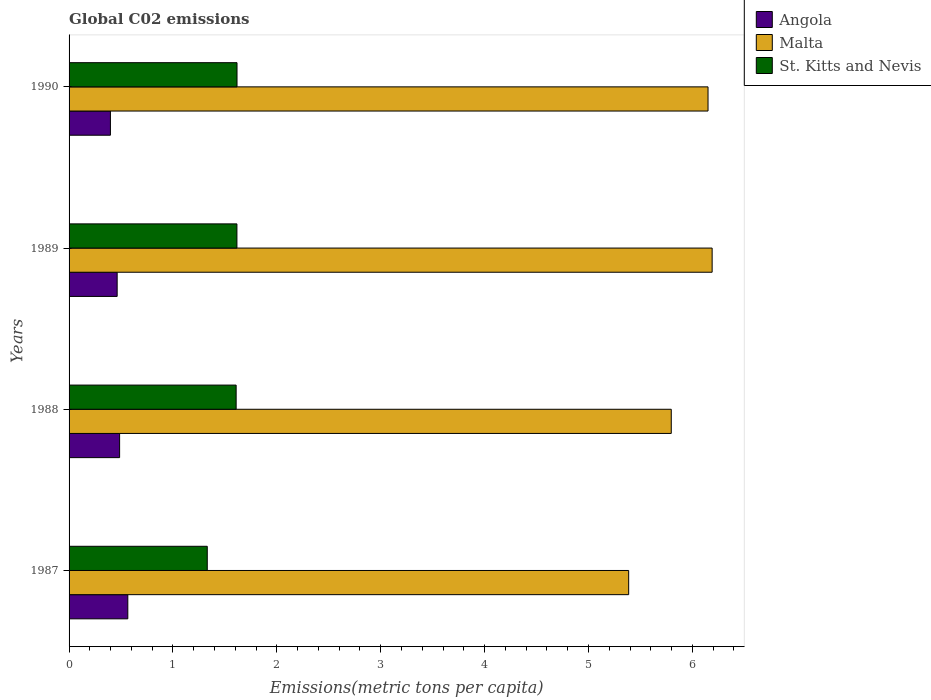How many groups of bars are there?
Provide a succinct answer. 4. Are the number of bars per tick equal to the number of legend labels?
Provide a succinct answer. Yes. Are the number of bars on each tick of the Y-axis equal?
Your answer should be compact. Yes. How many bars are there on the 2nd tick from the top?
Ensure brevity in your answer.  3. What is the label of the 4th group of bars from the top?
Your answer should be compact. 1987. What is the amount of CO2 emitted in in Angola in 1988?
Give a very brief answer. 0.49. Across all years, what is the maximum amount of CO2 emitted in in St. Kitts and Nevis?
Offer a terse response. 1.62. Across all years, what is the minimum amount of CO2 emitted in in Angola?
Ensure brevity in your answer.  0.4. In which year was the amount of CO2 emitted in in Malta maximum?
Give a very brief answer. 1989. In which year was the amount of CO2 emitted in in St. Kitts and Nevis minimum?
Your answer should be compact. 1987. What is the total amount of CO2 emitted in in St. Kitts and Nevis in the graph?
Your answer should be very brief. 6.17. What is the difference between the amount of CO2 emitted in in Angola in 1987 and that in 1990?
Your answer should be very brief. 0.17. What is the difference between the amount of CO2 emitted in in Angola in 1987 and the amount of CO2 emitted in in St. Kitts and Nevis in 1989?
Your answer should be very brief. -1.05. What is the average amount of CO2 emitted in in St. Kitts and Nevis per year?
Keep it short and to the point. 1.54. In the year 1987, what is the difference between the amount of CO2 emitted in in Angola and amount of CO2 emitted in in St. Kitts and Nevis?
Give a very brief answer. -0.76. In how many years, is the amount of CO2 emitted in in St. Kitts and Nevis greater than 2 metric tons per capita?
Make the answer very short. 0. What is the ratio of the amount of CO2 emitted in in St. Kitts and Nevis in 1987 to that in 1988?
Make the answer very short. 0.83. Is the amount of CO2 emitted in in St. Kitts and Nevis in 1989 less than that in 1990?
Your response must be concise. Yes. What is the difference between the highest and the second highest amount of CO2 emitted in in Angola?
Offer a very short reply. 0.08. What is the difference between the highest and the lowest amount of CO2 emitted in in Malta?
Offer a very short reply. 0.8. In how many years, is the amount of CO2 emitted in in St. Kitts and Nevis greater than the average amount of CO2 emitted in in St. Kitts and Nevis taken over all years?
Ensure brevity in your answer.  3. What does the 3rd bar from the top in 1988 represents?
Your response must be concise. Angola. What does the 2nd bar from the bottom in 1990 represents?
Give a very brief answer. Malta. How many years are there in the graph?
Keep it short and to the point. 4. What is the difference between two consecutive major ticks on the X-axis?
Give a very brief answer. 1. How are the legend labels stacked?
Your answer should be very brief. Vertical. What is the title of the graph?
Your answer should be compact. Global C02 emissions. Does "Eritrea" appear as one of the legend labels in the graph?
Offer a terse response. No. What is the label or title of the X-axis?
Ensure brevity in your answer.  Emissions(metric tons per capita). What is the label or title of the Y-axis?
Your answer should be very brief. Years. What is the Emissions(metric tons per capita) of Angola in 1987?
Provide a succinct answer. 0.57. What is the Emissions(metric tons per capita) of Malta in 1987?
Provide a succinct answer. 5.39. What is the Emissions(metric tons per capita) in St. Kitts and Nevis in 1987?
Keep it short and to the point. 1.33. What is the Emissions(metric tons per capita) of Angola in 1988?
Ensure brevity in your answer.  0.49. What is the Emissions(metric tons per capita) of Malta in 1988?
Provide a succinct answer. 5.8. What is the Emissions(metric tons per capita) of St. Kitts and Nevis in 1988?
Your response must be concise. 1.61. What is the Emissions(metric tons per capita) in Angola in 1989?
Your answer should be very brief. 0.46. What is the Emissions(metric tons per capita) in Malta in 1989?
Your response must be concise. 6.19. What is the Emissions(metric tons per capita) of St. Kitts and Nevis in 1989?
Provide a succinct answer. 1.62. What is the Emissions(metric tons per capita) of Angola in 1990?
Offer a terse response. 0.4. What is the Emissions(metric tons per capita) of Malta in 1990?
Your response must be concise. 6.15. What is the Emissions(metric tons per capita) in St. Kitts and Nevis in 1990?
Offer a terse response. 1.62. Across all years, what is the maximum Emissions(metric tons per capita) in Angola?
Provide a succinct answer. 0.57. Across all years, what is the maximum Emissions(metric tons per capita) of Malta?
Offer a terse response. 6.19. Across all years, what is the maximum Emissions(metric tons per capita) in St. Kitts and Nevis?
Provide a succinct answer. 1.62. Across all years, what is the minimum Emissions(metric tons per capita) in Angola?
Provide a short and direct response. 0.4. Across all years, what is the minimum Emissions(metric tons per capita) in Malta?
Your answer should be very brief. 5.39. Across all years, what is the minimum Emissions(metric tons per capita) of St. Kitts and Nevis?
Offer a very short reply. 1.33. What is the total Emissions(metric tons per capita) in Angola in the graph?
Your answer should be compact. 1.91. What is the total Emissions(metric tons per capita) of Malta in the graph?
Offer a very short reply. 23.52. What is the total Emissions(metric tons per capita) in St. Kitts and Nevis in the graph?
Give a very brief answer. 6.17. What is the difference between the Emissions(metric tons per capita) in Angola in 1987 and that in 1988?
Make the answer very short. 0.08. What is the difference between the Emissions(metric tons per capita) in Malta in 1987 and that in 1988?
Your response must be concise. -0.41. What is the difference between the Emissions(metric tons per capita) in St. Kitts and Nevis in 1987 and that in 1988?
Offer a very short reply. -0.28. What is the difference between the Emissions(metric tons per capita) of Angola in 1987 and that in 1989?
Ensure brevity in your answer.  0.1. What is the difference between the Emissions(metric tons per capita) in Malta in 1987 and that in 1989?
Your answer should be compact. -0.8. What is the difference between the Emissions(metric tons per capita) of St. Kitts and Nevis in 1987 and that in 1989?
Provide a short and direct response. -0.29. What is the difference between the Emissions(metric tons per capita) in Angola in 1987 and that in 1990?
Offer a terse response. 0.17. What is the difference between the Emissions(metric tons per capita) in Malta in 1987 and that in 1990?
Provide a succinct answer. -0.76. What is the difference between the Emissions(metric tons per capita) in St. Kitts and Nevis in 1987 and that in 1990?
Make the answer very short. -0.29. What is the difference between the Emissions(metric tons per capita) of Angola in 1988 and that in 1989?
Make the answer very short. 0.02. What is the difference between the Emissions(metric tons per capita) in Malta in 1988 and that in 1989?
Offer a terse response. -0.39. What is the difference between the Emissions(metric tons per capita) of St. Kitts and Nevis in 1988 and that in 1989?
Your answer should be compact. -0.01. What is the difference between the Emissions(metric tons per capita) in Angola in 1988 and that in 1990?
Ensure brevity in your answer.  0.09. What is the difference between the Emissions(metric tons per capita) of Malta in 1988 and that in 1990?
Provide a short and direct response. -0.35. What is the difference between the Emissions(metric tons per capita) in St. Kitts and Nevis in 1988 and that in 1990?
Your answer should be very brief. -0.01. What is the difference between the Emissions(metric tons per capita) of Angola in 1989 and that in 1990?
Provide a short and direct response. 0.06. What is the difference between the Emissions(metric tons per capita) in Malta in 1989 and that in 1990?
Provide a succinct answer. 0.04. What is the difference between the Emissions(metric tons per capita) in St. Kitts and Nevis in 1989 and that in 1990?
Make the answer very short. -0. What is the difference between the Emissions(metric tons per capita) in Angola in 1987 and the Emissions(metric tons per capita) in Malta in 1988?
Give a very brief answer. -5.23. What is the difference between the Emissions(metric tons per capita) in Angola in 1987 and the Emissions(metric tons per capita) in St. Kitts and Nevis in 1988?
Keep it short and to the point. -1.04. What is the difference between the Emissions(metric tons per capita) in Malta in 1987 and the Emissions(metric tons per capita) in St. Kitts and Nevis in 1988?
Offer a terse response. 3.78. What is the difference between the Emissions(metric tons per capita) in Angola in 1987 and the Emissions(metric tons per capita) in Malta in 1989?
Give a very brief answer. -5.62. What is the difference between the Emissions(metric tons per capita) in Angola in 1987 and the Emissions(metric tons per capita) in St. Kitts and Nevis in 1989?
Offer a very short reply. -1.05. What is the difference between the Emissions(metric tons per capita) in Malta in 1987 and the Emissions(metric tons per capita) in St. Kitts and Nevis in 1989?
Keep it short and to the point. 3.77. What is the difference between the Emissions(metric tons per capita) of Angola in 1987 and the Emissions(metric tons per capita) of Malta in 1990?
Offer a very short reply. -5.58. What is the difference between the Emissions(metric tons per capita) in Angola in 1987 and the Emissions(metric tons per capita) in St. Kitts and Nevis in 1990?
Provide a succinct answer. -1.05. What is the difference between the Emissions(metric tons per capita) in Malta in 1987 and the Emissions(metric tons per capita) in St. Kitts and Nevis in 1990?
Provide a short and direct response. 3.77. What is the difference between the Emissions(metric tons per capita) of Angola in 1988 and the Emissions(metric tons per capita) of Malta in 1989?
Provide a succinct answer. -5.7. What is the difference between the Emissions(metric tons per capita) in Angola in 1988 and the Emissions(metric tons per capita) in St. Kitts and Nevis in 1989?
Give a very brief answer. -1.13. What is the difference between the Emissions(metric tons per capita) in Malta in 1988 and the Emissions(metric tons per capita) in St. Kitts and Nevis in 1989?
Provide a succinct answer. 4.18. What is the difference between the Emissions(metric tons per capita) of Angola in 1988 and the Emissions(metric tons per capita) of Malta in 1990?
Keep it short and to the point. -5.66. What is the difference between the Emissions(metric tons per capita) of Angola in 1988 and the Emissions(metric tons per capita) of St. Kitts and Nevis in 1990?
Provide a short and direct response. -1.13. What is the difference between the Emissions(metric tons per capita) of Malta in 1988 and the Emissions(metric tons per capita) of St. Kitts and Nevis in 1990?
Provide a succinct answer. 4.18. What is the difference between the Emissions(metric tons per capita) of Angola in 1989 and the Emissions(metric tons per capita) of Malta in 1990?
Ensure brevity in your answer.  -5.69. What is the difference between the Emissions(metric tons per capita) of Angola in 1989 and the Emissions(metric tons per capita) of St. Kitts and Nevis in 1990?
Make the answer very short. -1.15. What is the difference between the Emissions(metric tons per capita) of Malta in 1989 and the Emissions(metric tons per capita) of St. Kitts and Nevis in 1990?
Offer a very short reply. 4.57. What is the average Emissions(metric tons per capita) in Angola per year?
Provide a succinct answer. 0.48. What is the average Emissions(metric tons per capita) in Malta per year?
Make the answer very short. 5.88. What is the average Emissions(metric tons per capita) in St. Kitts and Nevis per year?
Your answer should be compact. 1.54. In the year 1987, what is the difference between the Emissions(metric tons per capita) of Angola and Emissions(metric tons per capita) of Malta?
Make the answer very short. -4.82. In the year 1987, what is the difference between the Emissions(metric tons per capita) of Angola and Emissions(metric tons per capita) of St. Kitts and Nevis?
Make the answer very short. -0.76. In the year 1987, what is the difference between the Emissions(metric tons per capita) of Malta and Emissions(metric tons per capita) of St. Kitts and Nevis?
Your answer should be very brief. 4.06. In the year 1988, what is the difference between the Emissions(metric tons per capita) in Angola and Emissions(metric tons per capita) in Malta?
Offer a terse response. -5.31. In the year 1988, what is the difference between the Emissions(metric tons per capita) of Angola and Emissions(metric tons per capita) of St. Kitts and Nevis?
Your answer should be very brief. -1.12. In the year 1988, what is the difference between the Emissions(metric tons per capita) of Malta and Emissions(metric tons per capita) of St. Kitts and Nevis?
Keep it short and to the point. 4.19. In the year 1989, what is the difference between the Emissions(metric tons per capita) in Angola and Emissions(metric tons per capita) in Malta?
Provide a short and direct response. -5.73. In the year 1989, what is the difference between the Emissions(metric tons per capita) of Angola and Emissions(metric tons per capita) of St. Kitts and Nevis?
Provide a succinct answer. -1.15. In the year 1989, what is the difference between the Emissions(metric tons per capita) of Malta and Emissions(metric tons per capita) of St. Kitts and Nevis?
Make the answer very short. 4.57. In the year 1990, what is the difference between the Emissions(metric tons per capita) in Angola and Emissions(metric tons per capita) in Malta?
Offer a terse response. -5.75. In the year 1990, what is the difference between the Emissions(metric tons per capita) of Angola and Emissions(metric tons per capita) of St. Kitts and Nevis?
Your answer should be very brief. -1.22. In the year 1990, what is the difference between the Emissions(metric tons per capita) of Malta and Emissions(metric tons per capita) of St. Kitts and Nevis?
Your response must be concise. 4.53. What is the ratio of the Emissions(metric tons per capita) in Angola in 1987 to that in 1988?
Give a very brief answer. 1.16. What is the ratio of the Emissions(metric tons per capita) of Malta in 1987 to that in 1988?
Ensure brevity in your answer.  0.93. What is the ratio of the Emissions(metric tons per capita) of St. Kitts and Nevis in 1987 to that in 1988?
Give a very brief answer. 0.83. What is the ratio of the Emissions(metric tons per capita) of Angola in 1987 to that in 1989?
Your answer should be compact. 1.22. What is the ratio of the Emissions(metric tons per capita) of Malta in 1987 to that in 1989?
Your answer should be compact. 0.87. What is the ratio of the Emissions(metric tons per capita) of St. Kitts and Nevis in 1987 to that in 1989?
Your response must be concise. 0.82. What is the ratio of the Emissions(metric tons per capita) in Angola in 1987 to that in 1990?
Offer a terse response. 1.42. What is the ratio of the Emissions(metric tons per capita) of Malta in 1987 to that in 1990?
Your answer should be very brief. 0.88. What is the ratio of the Emissions(metric tons per capita) of St. Kitts and Nevis in 1987 to that in 1990?
Offer a terse response. 0.82. What is the ratio of the Emissions(metric tons per capita) of Angola in 1988 to that in 1989?
Give a very brief answer. 1.05. What is the ratio of the Emissions(metric tons per capita) in Malta in 1988 to that in 1989?
Offer a terse response. 0.94. What is the ratio of the Emissions(metric tons per capita) in St. Kitts and Nevis in 1988 to that in 1989?
Your answer should be very brief. 1. What is the ratio of the Emissions(metric tons per capita) of Angola in 1988 to that in 1990?
Offer a very short reply. 1.22. What is the ratio of the Emissions(metric tons per capita) of Malta in 1988 to that in 1990?
Make the answer very short. 0.94. What is the ratio of the Emissions(metric tons per capita) of Angola in 1989 to that in 1990?
Your response must be concise. 1.16. What is the ratio of the Emissions(metric tons per capita) of Malta in 1989 to that in 1990?
Keep it short and to the point. 1.01. What is the difference between the highest and the second highest Emissions(metric tons per capita) in Angola?
Keep it short and to the point. 0.08. What is the difference between the highest and the second highest Emissions(metric tons per capita) in Malta?
Your answer should be compact. 0.04. What is the difference between the highest and the second highest Emissions(metric tons per capita) in St. Kitts and Nevis?
Provide a short and direct response. 0. What is the difference between the highest and the lowest Emissions(metric tons per capita) of Angola?
Offer a terse response. 0.17. What is the difference between the highest and the lowest Emissions(metric tons per capita) of Malta?
Give a very brief answer. 0.8. What is the difference between the highest and the lowest Emissions(metric tons per capita) of St. Kitts and Nevis?
Give a very brief answer. 0.29. 